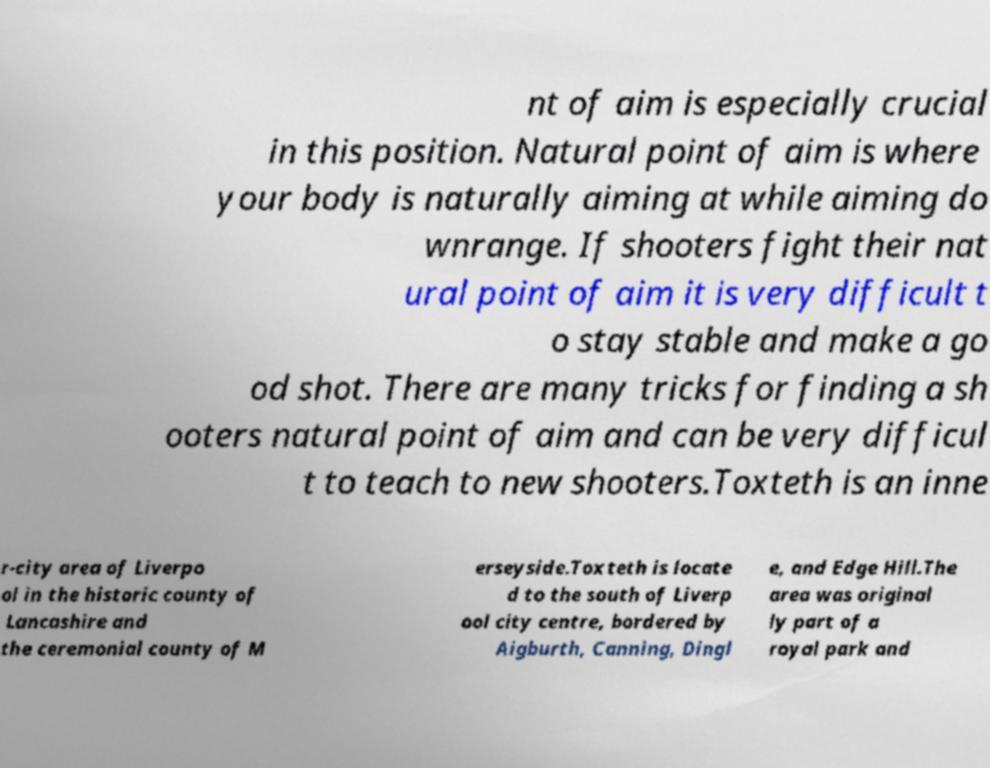Please identify and transcribe the text found in this image. nt of aim is especially crucial in this position. Natural point of aim is where your body is naturally aiming at while aiming do wnrange. If shooters fight their nat ural point of aim it is very difficult t o stay stable and make a go od shot. There are many tricks for finding a sh ooters natural point of aim and can be very difficul t to teach to new shooters.Toxteth is an inne r-city area of Liverpo ol in the historic county of Lancashire and the ceremonial county of M erseyside.Toxteth is locate d to the south of Liverp ool city centre, bordered by Aigburth, Canning, Dingl e, and Edge Hill.The area was original ly part of a royal park and 